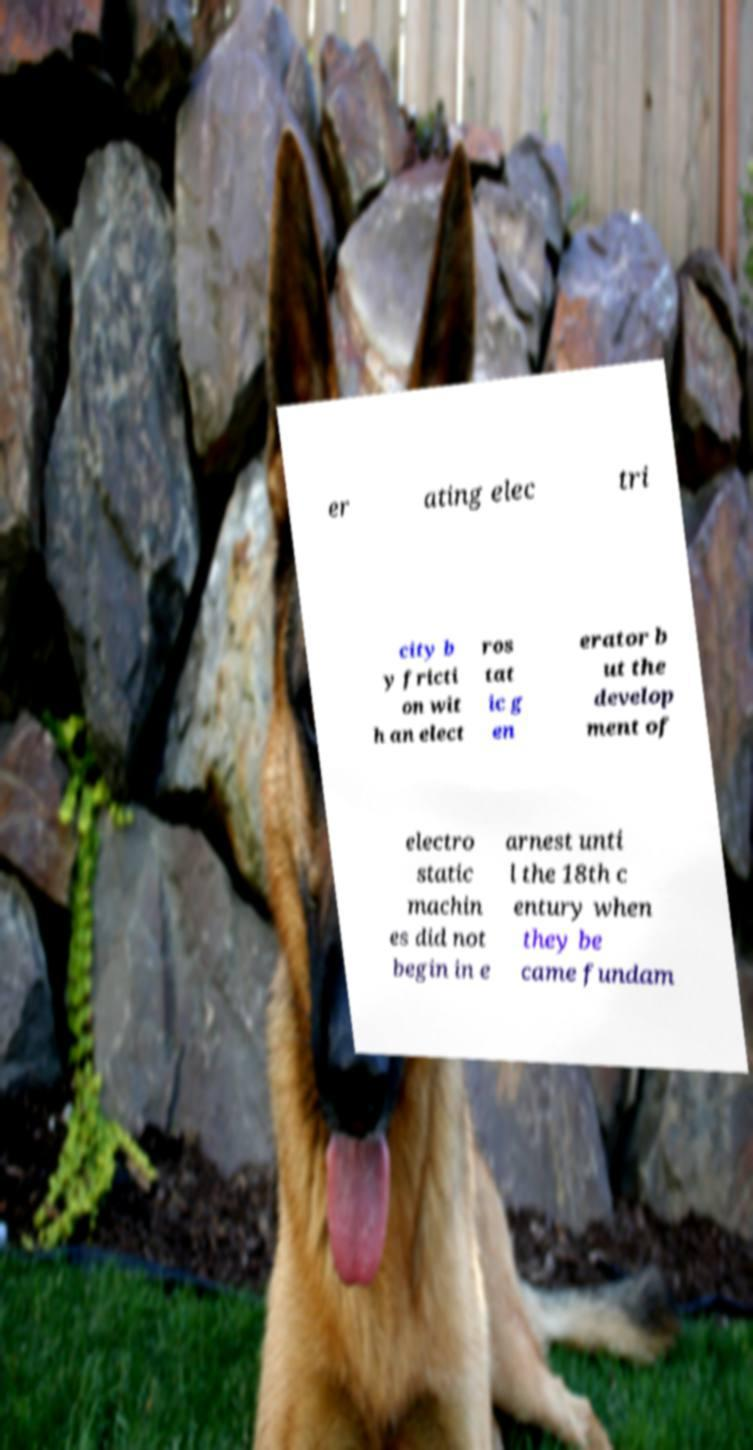There's text embedded in this image that I need extracted. Can you transcribe it verbatim? er ating elec tri city b y fricti on wit h an elect ros tat ic g en erator b ut the develop ment of electro static machin es did not begin in e arnest unti l the 18th c entury when they be came fundam 